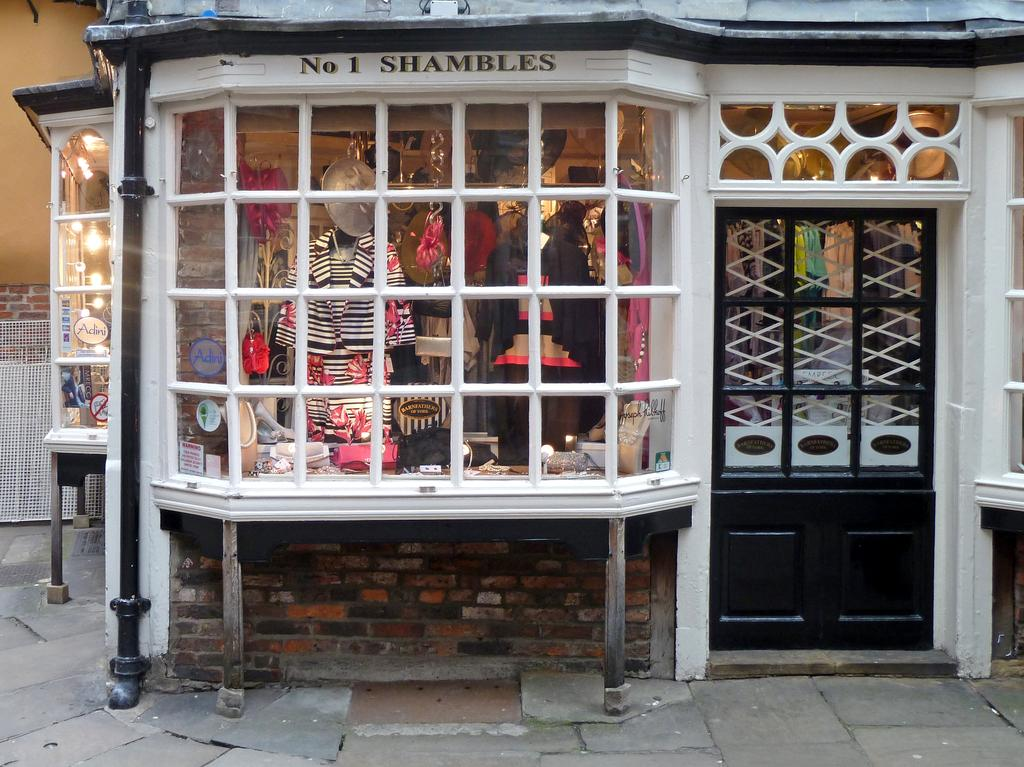What type of establishment is depicted in the image? There is a shop in the image. What can be seen inside the shop? There are lights, clothes, and other objects in the shop. How might customers enter or exit the shop? There is a door in the shop for customers to enter or exit. What type of quill is used to write the shop's name on the sign outside? There is no quill present in the image, and the shop's name is not mentioned. 